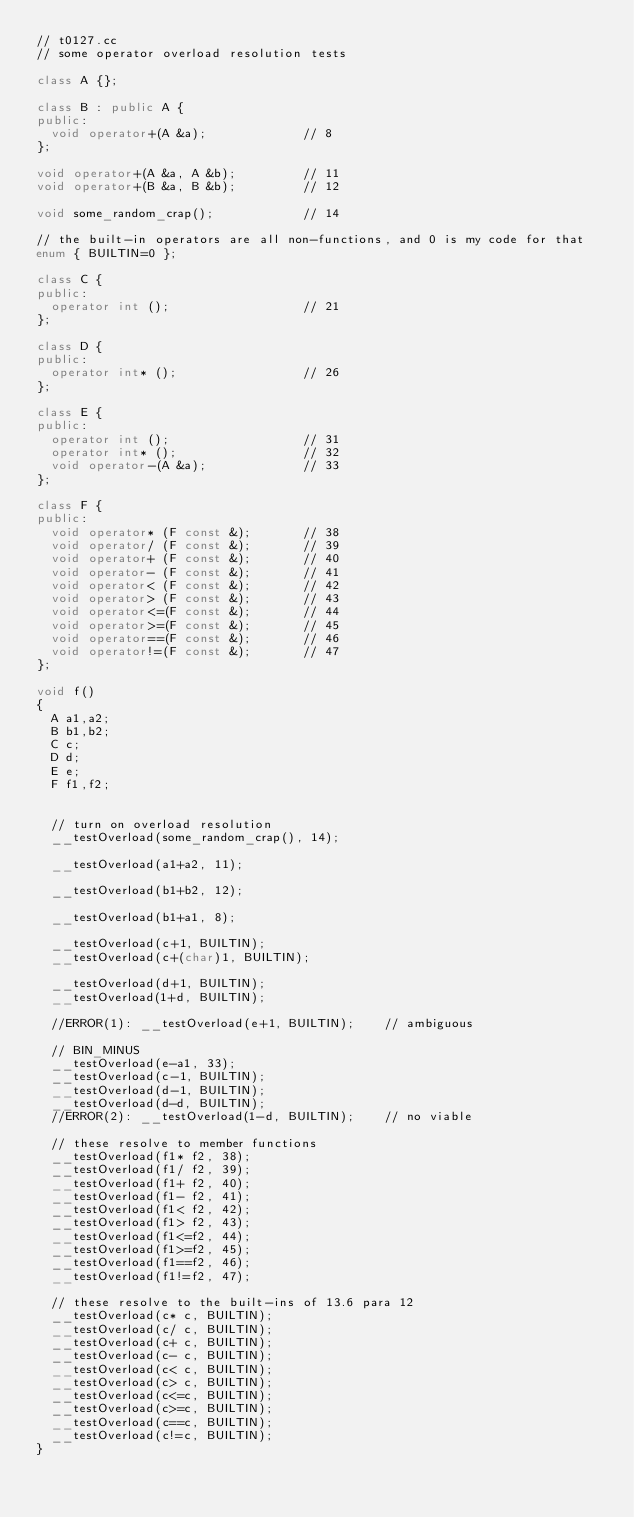<code> <loc_0><loc_0><loc_500><loc_500><_C++_>// t0127.cc
// some operator overload resolution tests

class A {};

class B : public A {
public:
  void operator+(A &a);             // 8
};

void operator+(A &a, A &b);         // 11
void operator+(B &a, B &b);         // 12

void some_random_crap();            // 14

// the built-in operators are all non-functions, and 0 is my code for that
enum { BUILTIN=0 };

class C {
public:
  operator int ();                  // 21
};

class D {
public:
  operator int* ();                 // 26
};

class E {
public:
  operator int ();                  // 31
  operator int* ();                 // 32
  void operator-(A &a);             // 33
};

class F {
public:
  void operator* (F const &);       // 38
  void operator/ (F const &);       // 39
  void operator+ (F const &);       // 40
  void operator- (F const &);       // 41
  void operator< (F const &);       // 42
  void operator> (F const &);       // 43
  void operator<=(F const &);       // 44
  void operator>=(F const &);       // 45
  void operator==(F const &);       // 46
  void operator!=(F const &);       // 47
};

void f()
{
  A a1,a2;
  B b1,b2;
  C c;
  D d;
  E e;
  F f1,f2;


  // turn on overload resolution
  __testOverload(some_random_crap(), 14);

  __testOverload(a1+a2, 11);

  __testOverload(b1+b2, 12);

  __testOverload(b1+a1, 8);

  __testOverload(c+1, BUILTIN);
  __testOverload(c+(char)1, BUILTIN);

  __testOverload(d+1, BUILTIN);
  __testOverload(1+d, BUILTIN);

  //ERROR(1): __testOverload(e+1, BUILTIN);    // ambiguous

  // BIN_MINUS
  __testOverload(e-a1, 33);
  __testOverload(c-1, BUILTIN);
  __testOverload(d-1, BUILTIN);
  __testOverload(d-d, BUILTIN);
  //ERROR(2): __testOverload(1-d, BUILTIN);    // no viable

  // these resolve to member functions
  __testOverload(f1* f2, 38);
  __testOverload(f1/ f2, 39);
  __testOverload(f1+ f2, 40);
  __testOverload(f1- f2, 41);
  __testOverload(f1< f2, 42);
  __testOverload(f1> f2, 43);
  __testOverload(f1<=f2, 44);
  __testOverload(f1>=f2, 45);
  __testOverload(f1==f2, 46);
  __testOverload(f1!=f2, 47);

  // these resolve to the built-ins of 13.6 para 12
  __testOverload(c* c, BUILTIN);
  __testOverload(c/ c, BUILTIN);
  __testOverload(c+ c, BUILTIN);
  __testOverload(c- c, BUILTIN);
  __testOverload(c< c, BUILTIN);
  __testOverload(c> c, BUILTIN);
  __testOverload(c<=c, BUILTIN);
  __testOverload(c>=c, BUILTIN);
  __testOverload(c==c, BUILTIN);
  __testOverload(c!=c, BUILTIN);
}
</code> 